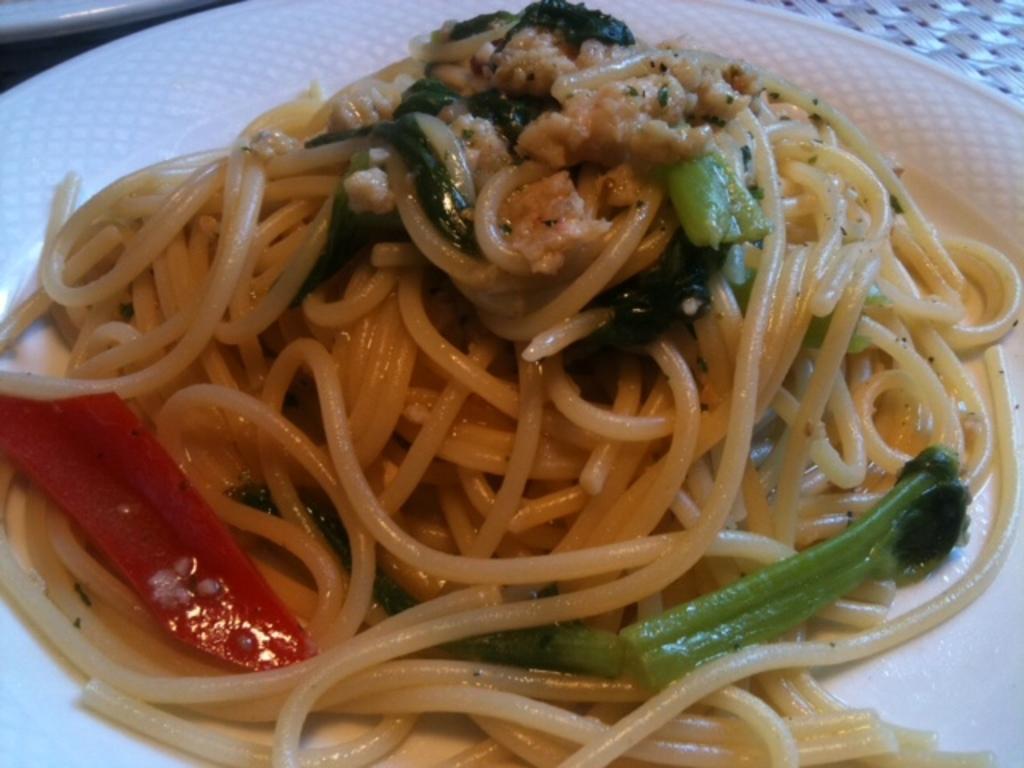Can you describe this image briefly? In this image there is a plate having noodles , broccoli and some food on it. Left top there is a plate. 